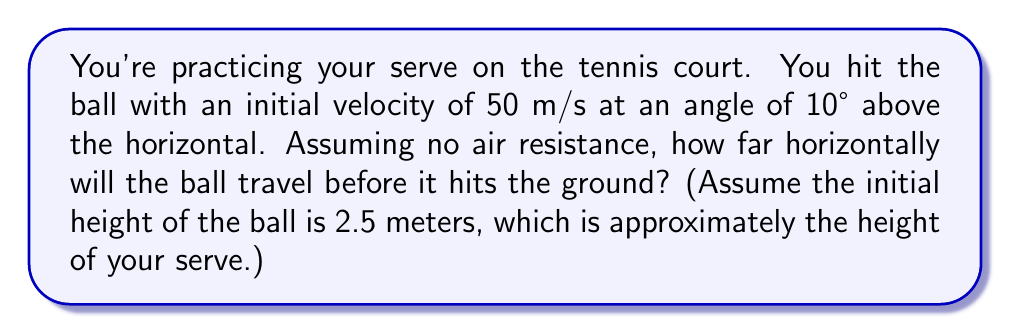Can you solve this math problem? Let's approach this step-by-step using projectile motion equations:

1) First, we need to break down the initial velocity into its horizontal and vertical components:

   $v_{0x} = v_0 \cos(\theta) = 50 \cos(10°) = 49.24$ m/s
   $v_{0y} = v_0 \sin(\theta) = 50 \sin(10°) = 8.68$ m/s

2) The time of flight can be calculated using the equation:

   $$y = y_0 + v_{0y}t - \frac{1}{2}gt^2$$

   Where $y = 0$ (ground level), $y_0 = 2.5$ m (initial height), $g = 9.8$ m/s².

3) Substituting these values:

   $$0 = 2.5 + 8.68t - 4.9t^2$$

4) This is a quadratic equation. Solving for t:

   $$4.9t^2 - 8.68t - 2.5 = 0$$

   Using the quadratic formula, we get:
   
   $$t = \frac{8.68 \pm \sqrt{8.68^2 + 4(4.9)(2.5)}}{2(4.9)} = 1.94 \text{ seconds}$$

   (We take the positive root as time cannot be negative)

5) Now that we have the time of flight, we can calculate the horizontal distance using:

   $$x = v_{0x}t$$

6) Substituting the values:

   $$x = 49.24 \times 1.94 = 95.53 \text{ meters}$$

Therefore, the ball will travel approximately 95.53 meters horizontally before hitting the ground.
Answer: 95.53 meters 